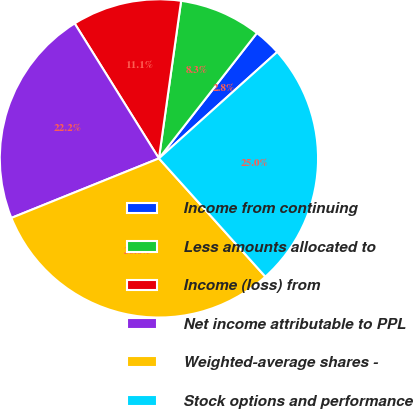Convert chart. <chart><loc_0><loc_0><loc_500><loc_500><pie_chart><fcel>Income from continuing<fcel>Less amounts allocated to<fcel>Income (loss) from<fcel>Net income attributable to PPL<fcel>Weighted-average shares -<fcel>Stock options and performance<nl><fcel>2.78%<fcel>8.33%<fcel>11.11%<fcel>22.22%<fcel>30.56%<fcel>25.0%<nl></chart> 